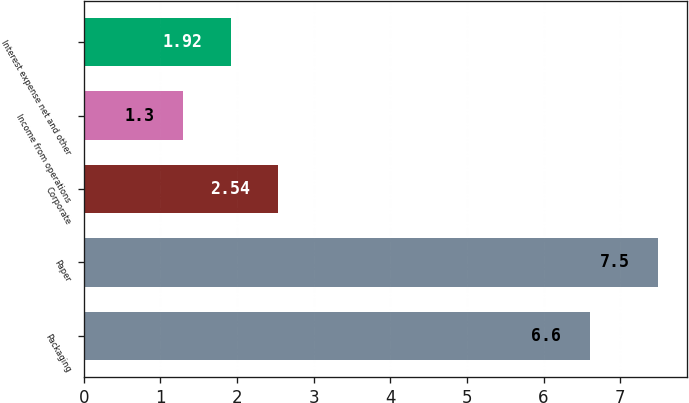Convert chart. <chart><loc_0><loc_0><loc_500><loc_500><bar_chart><fcel>Packaging<fcel>Paper<fcel>Corporate<fcel>Income from operations<fcel>Interest expense net and other<nl><fcel>6.6<fcel>7.5<fcel>2.54<fcel>1.3<fcel>1.92<nl></chart> 